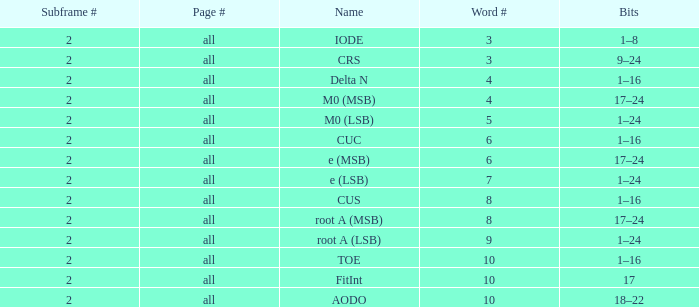Would you mind parsing the complete table? {'header': ['Subframe #', 'Page #', 'Name', 'Word #', 'Bits'], 'rows': [['2', 'all', 'IODE', '3', '1–8'], ['2', 'all', 'CRS', '3', '9–24'], ['2', 'all', 'Delta N', '4', '1–16'], ['2', 'all', 'M0 (MSB)', '4', '17–24'], ['2', 'all', 'M0 (LSB)', '5', '1–24'], ['2', 'all', 'CUC', '6', '1–16'], ['2', 'all', 'e (MSB)', '6', '17–24'], ['2', 'all', 'e (LSB)', '7', '1–24'], ['2', 'all', 'CUS', '8', '1–16'], ['2', 'all', 'root A (MSB)', '8', '17–24'], ['2', 'all', 'root A (LSB)', '9', '1–24'], ['2', 'all', 'TOE', '10', '1–16'], ['2', 'all', 'FitInt', '10', '17'], ['2', 'all', 'AODO', '10', '18–22']]} What is the typical word count with crs and subframes below 2? None. 